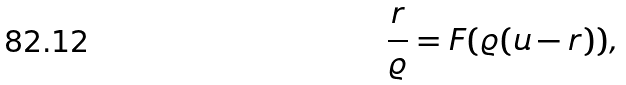Convert formula to latex. <formula><loc_0><loc_0><loc_500><loc_500>\frac { r } { \varrho } = F ( \varrho ( u - r ) ) ,</formula> 